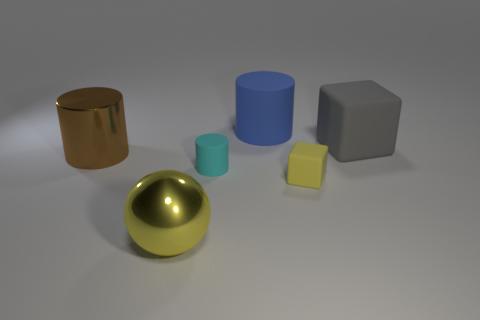What number of big shiny spheres are there?
Your answer should be compact. 1. What number of tiny objects are yellow metal spheres or gray rubber blocks?
Keep it short and to the point. 0. The gray thing that is the same size as the blue object is what shape?
Offer a very short reply. Cube. Is there any other thing that is the same size as the yellow metal sphere?
Your answer should be compact. Yes. What is the material of the large cylinder that is behind the cylinder that is on the left side of the small cyan object?
Offer a very short reply. Rubber. Do the blue matte cylinder and the gray matte object have the same size?
Offer a very short reply. Yes. What number of objects are things that are behind the gray cube or cyan things?
Give a very brief answer. 2. What is the shape of the small object that is on the right side of the rubber cylinder that is in front of the big gray object?
Make the answer very short. Cube. Is the size of the blue rubber object the same as the yellow rubber block in front of the brown shiny cylinder?
Provide a short and direct response. No. What material is the cube that is in front of the gray matte cube?
Your answer should be compact. Rubber. 